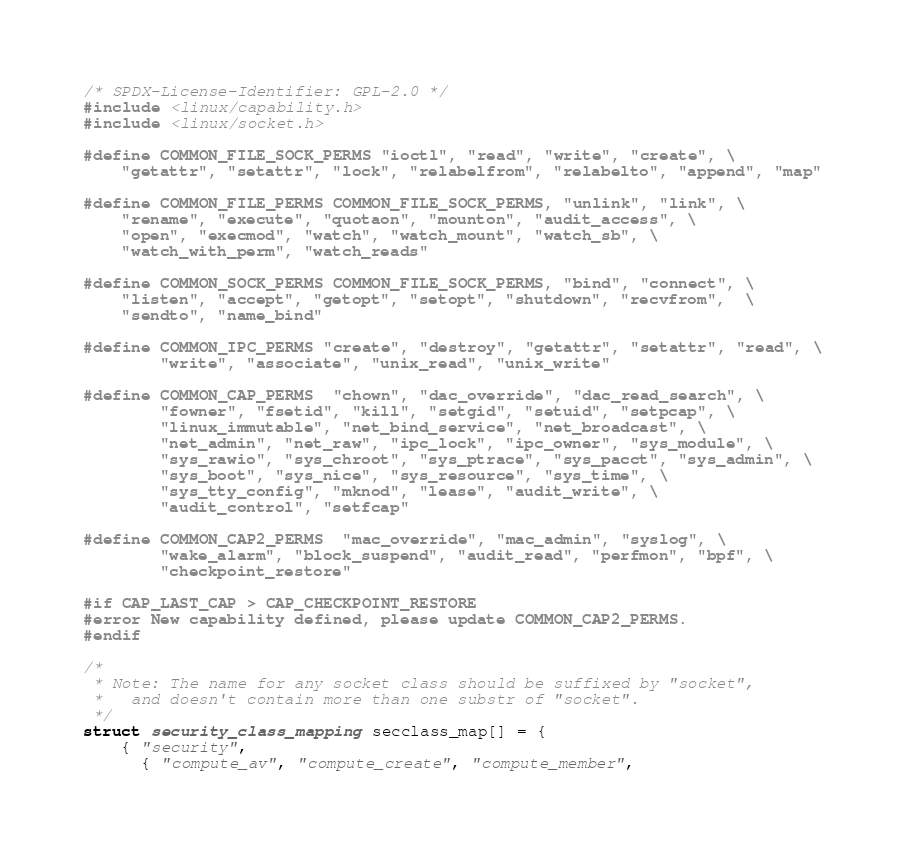Convert code to text. <code><loc_0><loc_0><loc_500><loc_500><_C_>/* SPDX-License-Identifier: GPL-2.0 */
#include <linux/capability.h>
#include <linux/socket.h>

#define COMMON_FILE_SOCK_PERMS "ioctl", "read", "write", "create", \
    "getattr", "setattr", "lock", "relabelfrom", "relabelto", "append", "map"

#define COMMON_FILE_PERMS COMMON_FILE_SOCK_PERMS, "unlink", "link", \
    "rename", "execute", "quotaon", "mounton", "audit_access", \
	"open", "execmod", "watch", "watch_mount", "watch_sb", \
	"watch_with_perm", "watch_reads"

#define COMMON_SOCK_PERMS COMMON_FILE_SOCK_PERMS, "bind", "connect", \
    "listen", "accept", "getopt", "setopt", "shutdown", "recvfrom",  \
    "sendto", "name_bind"

#define COMMON_IPC_PERMS "create", "destroy", "getattr", "setattr", "read", \
	    "write", "associate", "unix_read", "unix_write"

#define COMMON_CAP_PERMS  "chown", "dac_override", "dac_read_search", \
	    "fowner", "fsetid", "kill", "setgid", "setuid", "setpcap", \
	    "linux_immutable", "net_bind_service", "net_broadcast", \
	    "net_admin", "net_raw", "ipc_lock", "ipc_owner", "sys_module", \
	    "sys_rawio", "sys_chroot", "sys_ptrace", "sys_pacct", "sys_admin", \
	    "sys_boot", "sys_nice", "sys_resource", "sys_time", \
	    "sys_tty_config", "mknod", "lease", "audit_write", \
	    "audit_control", "setfcap"

#define COMMON_CAP2_PERMS  "mac_override", "mac_admin", "syslog", \
		"wake_alarm", "block_suspend", "audit_read", "perfmon", "bpf", \
		"checkpoint_restore"

#if CAP_LAST_CAP > CAP_CHECKPOINT_RESTORE
#error New capability defined, please update COMMON_CAP2_PERMS.
#endif

/*
 * Note: The name for any socket class should be suffixed by "socket",
 *	 and doesn't contain more than one substr of "socket".
 */
struct security_class_mapping secclass_map[] = {
	{ "security",
	  { "compute_av", "compute_create", "compute_member",</code> 